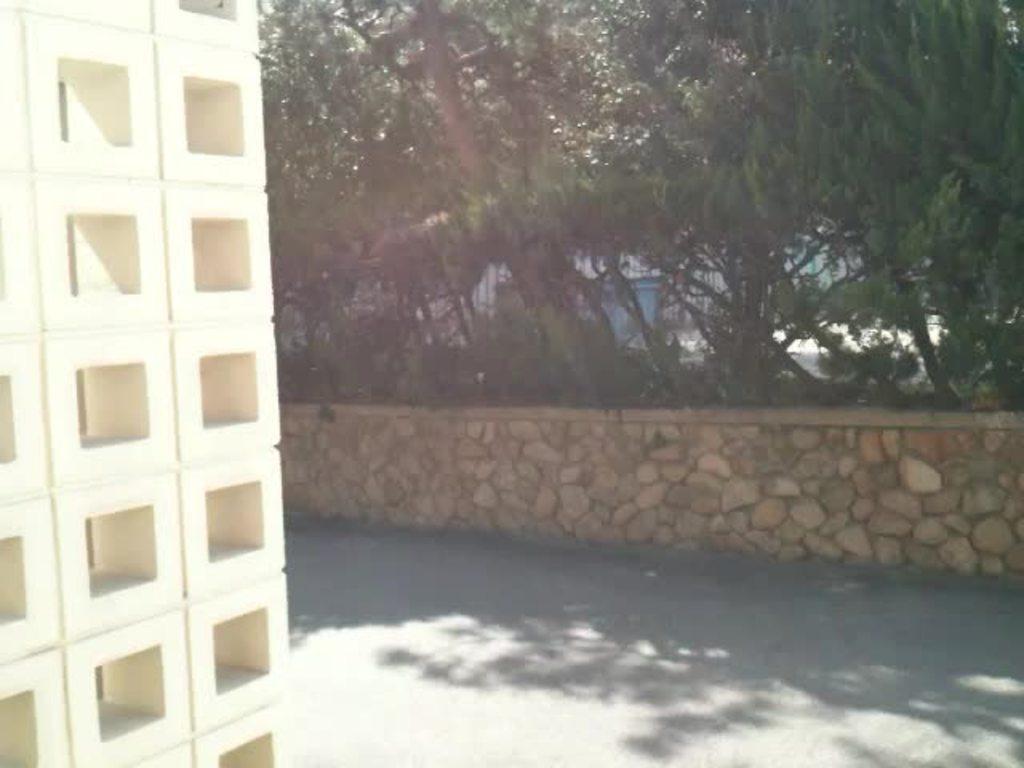Could you give a brief overview of what you see in this image? In this image I can see trees in green color. Background I can see some object in blue color. 